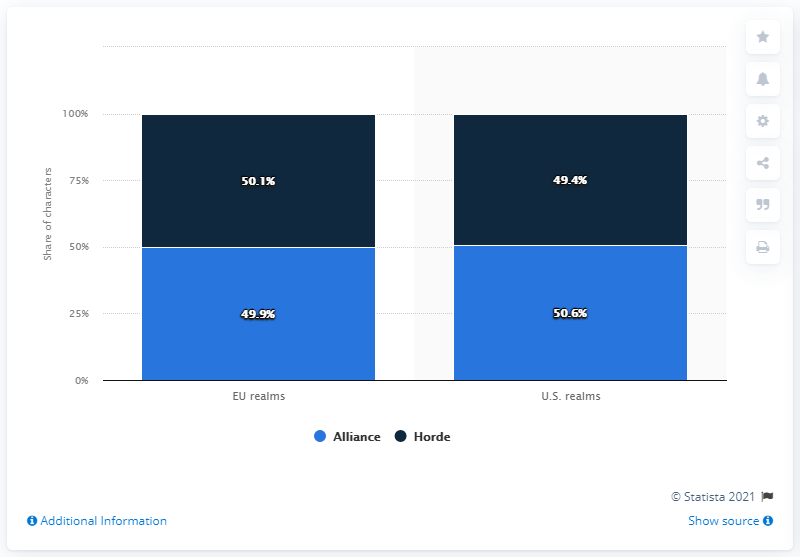Outline some significant characteristics in this image. According to the U.S. realms, 50.1% of all characters were members of the Alliance. 